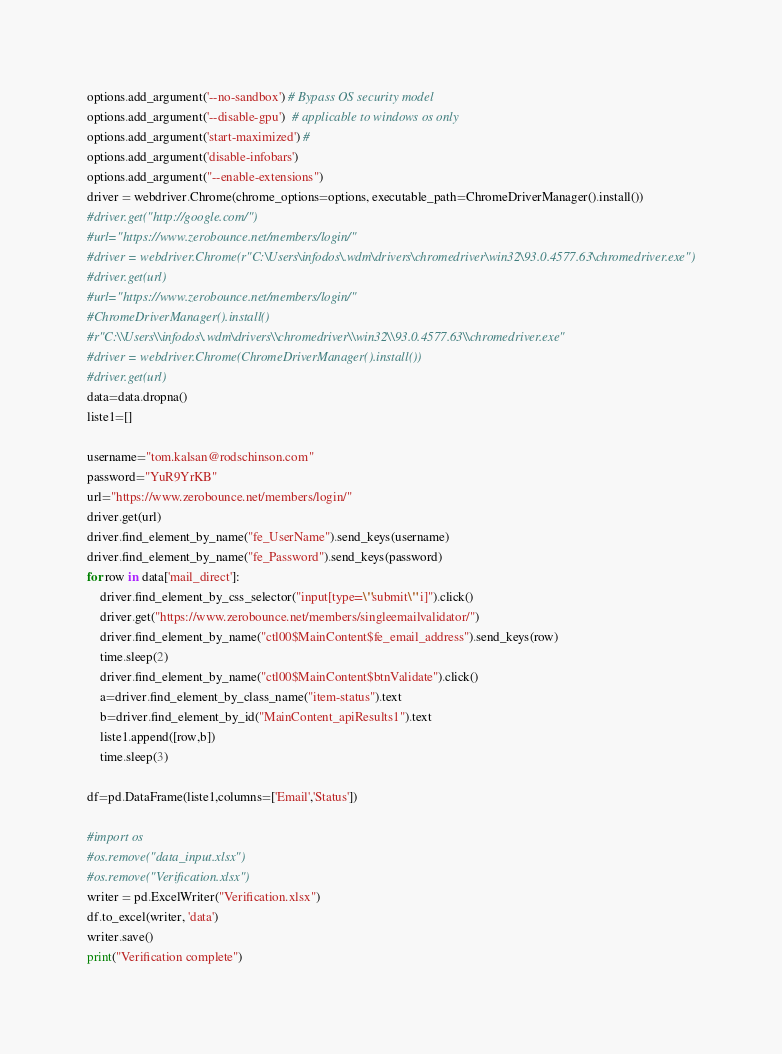<code> <loc_0><loc_0><loc_500><loc_500><_Python_>options.add_argument('--no-sandbox') # Bypass OS security model
options.add_argument('--disable-gpu')  # applicable to windows os only
options.add_argument('start-maximized') # 
options.add_argument('disable-infobars')
options.add_argument("--enable-extensions")
driver = webdriver.Chrome(chrome_options=options, executable_path=ChromeDriverManager().install())
#driver.get("http://google.com/")
#url="https://www.zerobounce.net/members/login/"
#driver = webdriver.Chrome(r"C:\Users\infodos\.wdm\drivers\chromedriver\win32\93.0.4577.63\chromedriver.exe")
#driver.get(url)
#url="https://www.zerobounce.net/members/login/"
#ChromeDriverManager().install()
#r"C:\\Users\\infodos\.wdm\drivers\\chromedriver\\win32\\93.0.4577.63\\chromedriver.exe"
#driver = webdriver.Chrome(ChromeDriverManager().install())
#driver.get(url)
data=data.dropna()
liste1=[]
    
username="tom.kalsan@rodschinson.com"
password="YuR9YrKB"
url="https://www.zerobounce.net/members/login/"
driver.get(url)
driver.find_element_by_name("fe_UserName").send_keys(username)
driver.find_element_by_name("fe_Password").send_keys(password)
for row in data['mail_direct']:
    driver.find_element_by_css_selector("input[type=\"submit\" i]").click()
    driver.get("https://www.zerobounce.net/members/singleemailvalidator/")
    driver.find_element_by_name("ctl00$MainContent$fe_email_address").send_keys(row)
    time.sleep(2)
    driver.find_element_by_name("ctl00$MainContent$btnValidate").click()
    a=driver.find_element_by_class_name("item-status").text
    b=driver.find_element_by_id("MainContent_apiResults1").text 
    liste1.append([row,b])
    time.sleep(3)

df=pd.DataFrame(liste1,columns=['Email','Status'])

#import os
#os.remove("data_input.xlsx")
#os.remove("Verification.xlsx")
writer = pd.ExcelWriter("Verification.xlsx")
df.to_excel(writer, 'data')
writer.save()
print("Verification complete")</code> 